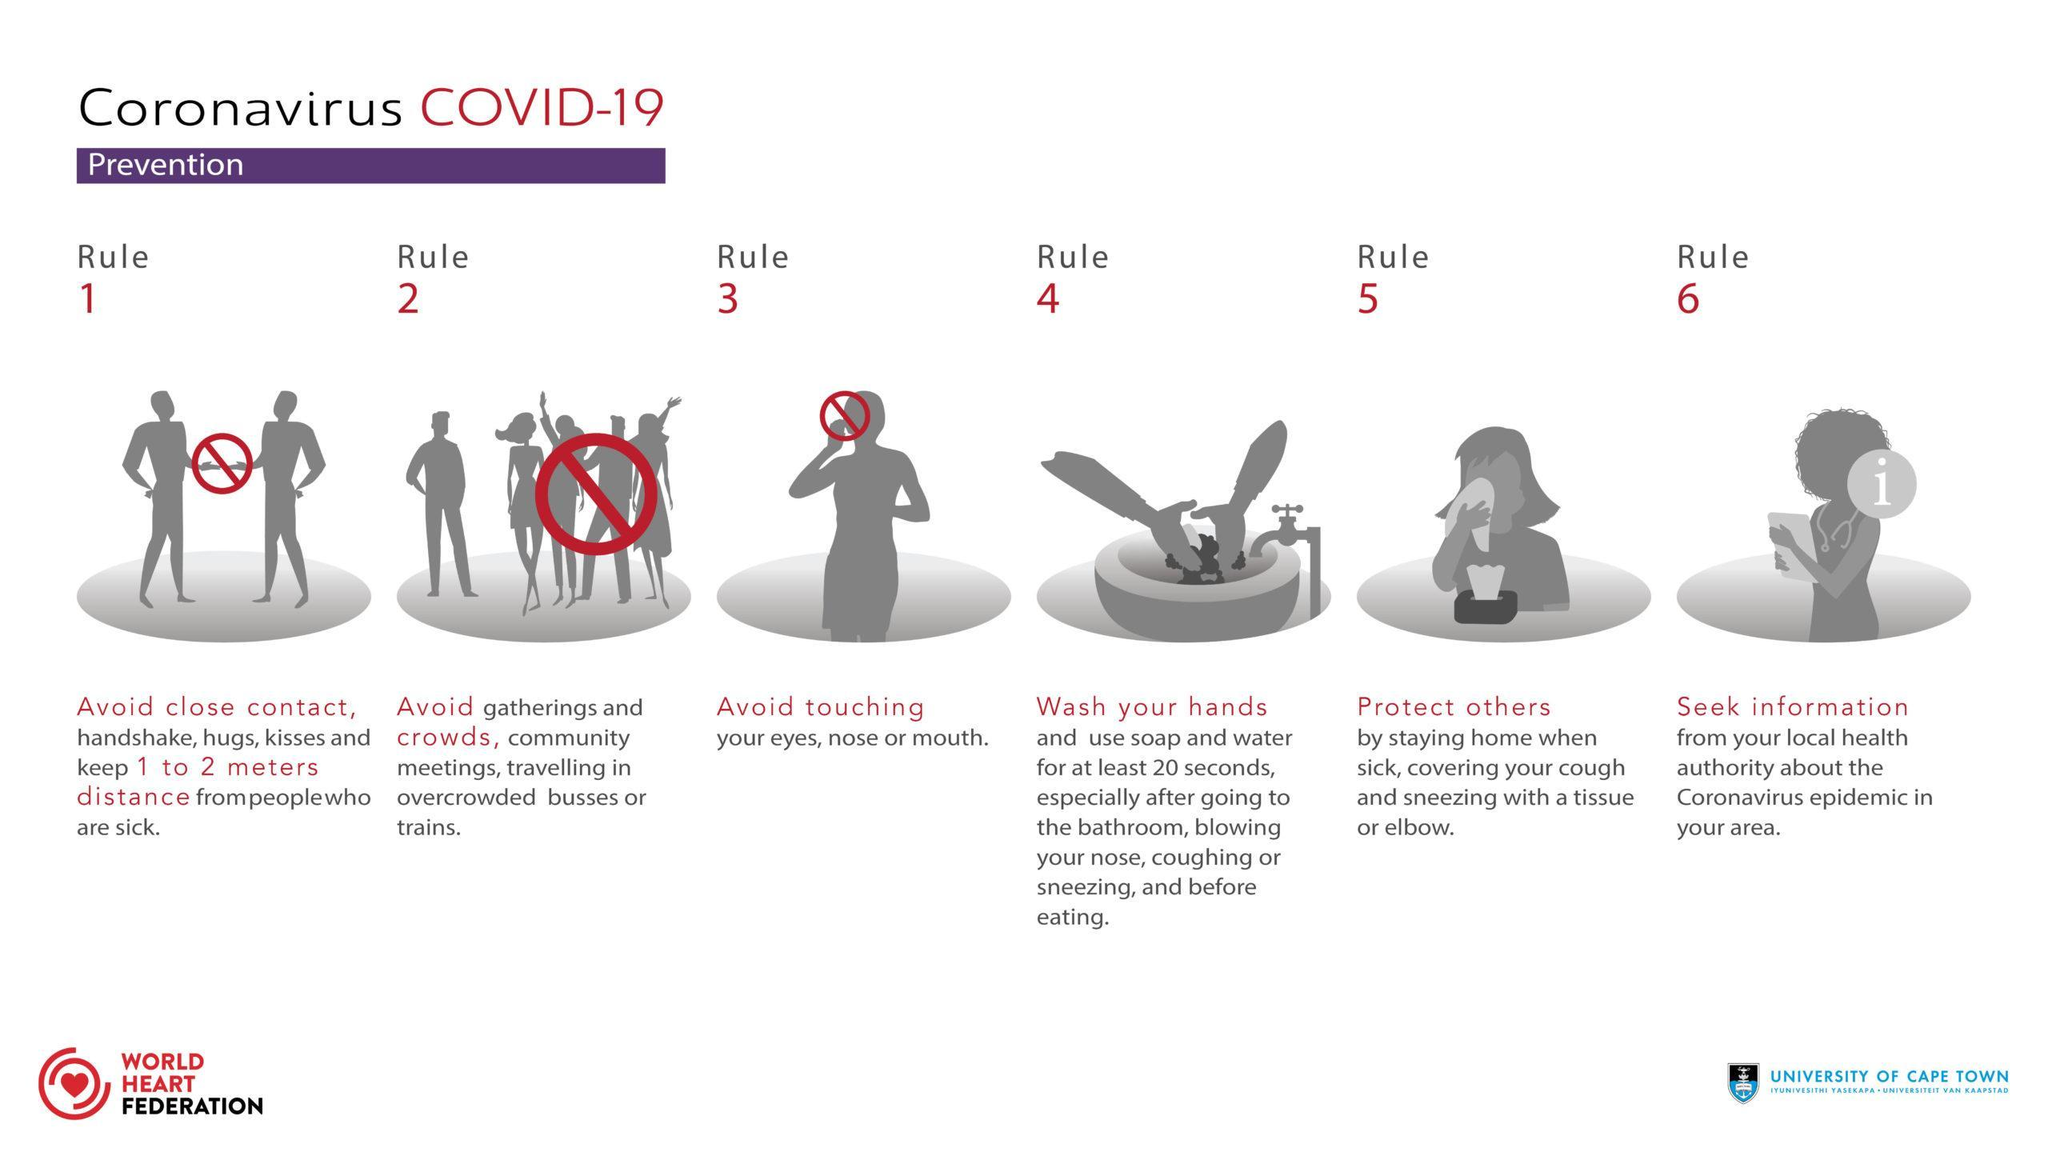How many don't are shown in this infographic image?
Answer the question with a short phrase. 3 